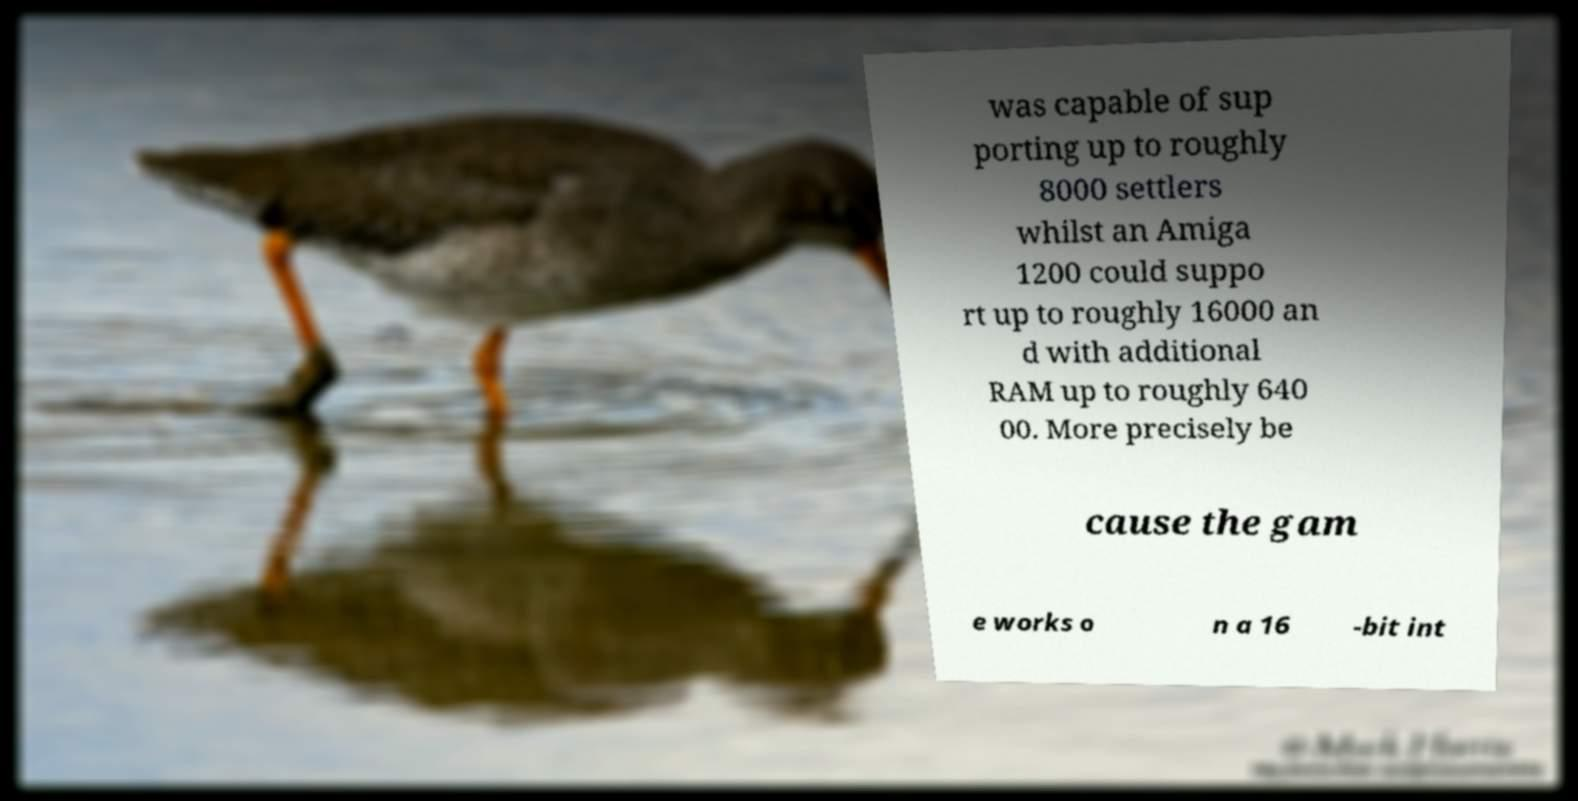For documentation purposes, I need the text within this image transcribed. Could you provide that? was capable of sup porting up to roughly 8000 settlers whilst an Amiga 1200 could suppo rt up to roughly 16000 an d with additional RAM up to roughly 640 00. More precisely be cause the gam e works o n a 16 -bit int 